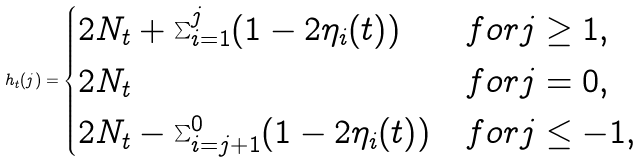<formula> <loc_0><loc_0><loc_500><loc_500>h _ { t } ( j ) = \begin{cases} 2 N _ { t } + \sum ^ { j } _ { i = 1 } ( 1 - 2 \eta _ { i } ( t ) ) & f o r j \geq 1 , \\ 2 N _ { t } & f o r j = 0 , \\ 2 N _ { t } - \sum ^ { 0 } _ { i = j + 1 } ( 1 - 2 \eta _ { i } ( t ) ) & f o r j \leq - 1 , \end{cases}</formula> 